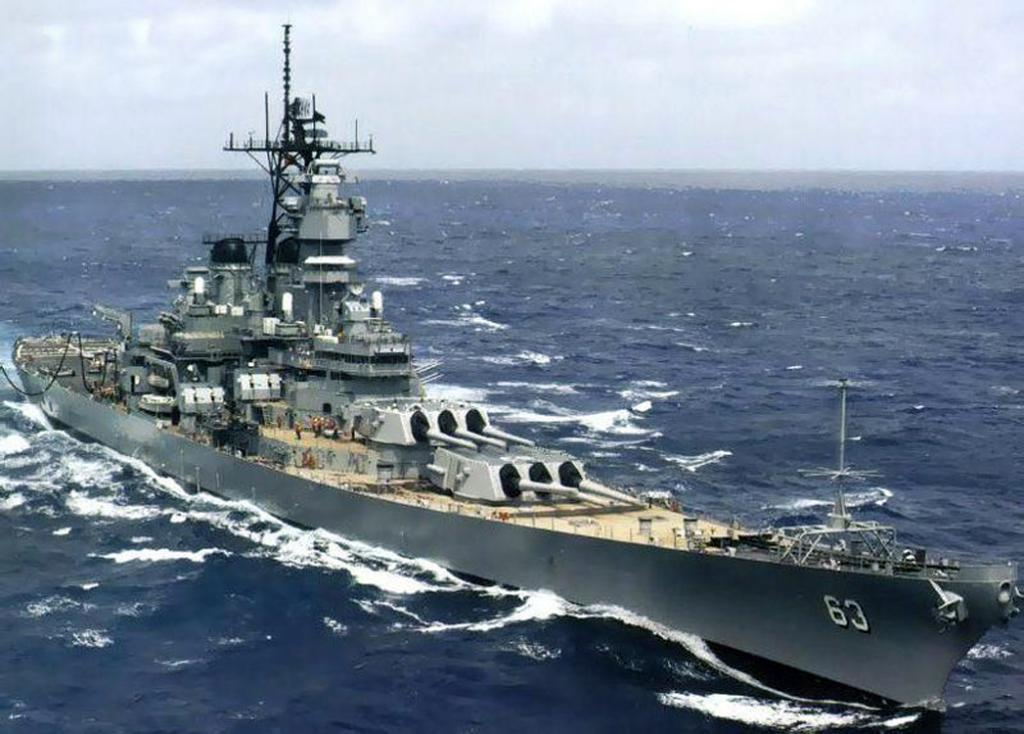What type of vehicle is in the image? There is a naval ship in the image. What is the ship doing in the image? The ship appears to be moving on the water. What body of water might the ship be on? The water is likely to be the sea. What else can be seen in the image besides the ship? The sky is visible in the image. How many girls are playing music on the ship in the image? There are no girls or music present in the image; it features a naval ship moving on the water. 